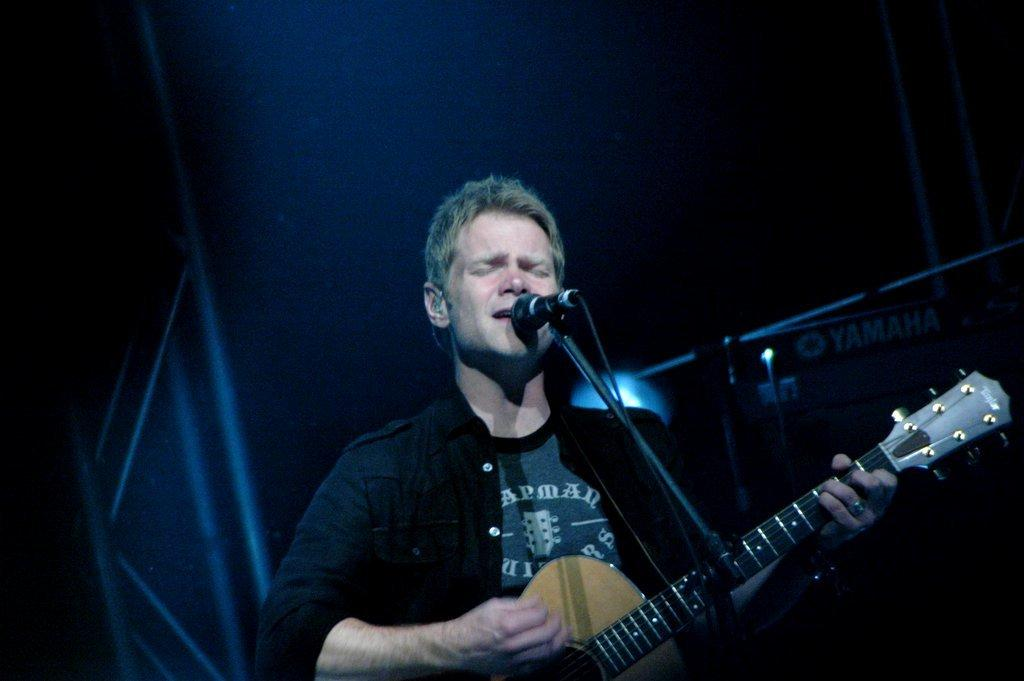What is the man in the image doing? The man is playing a guitar in the image. What is the man wearing? The man is wearing a black color shirt. What objects are present in the image that might be used for amplifying sound? There are microphones in the image. What type of hospital equipment can be seen in the image? There is no hospital equipment present in the image; it features a man playing a guitar and microphones. What committee is responsible for organizing the event in the image? There is no event or committee mentioned in the image; it only shows a man playing a guitar and microphones. 